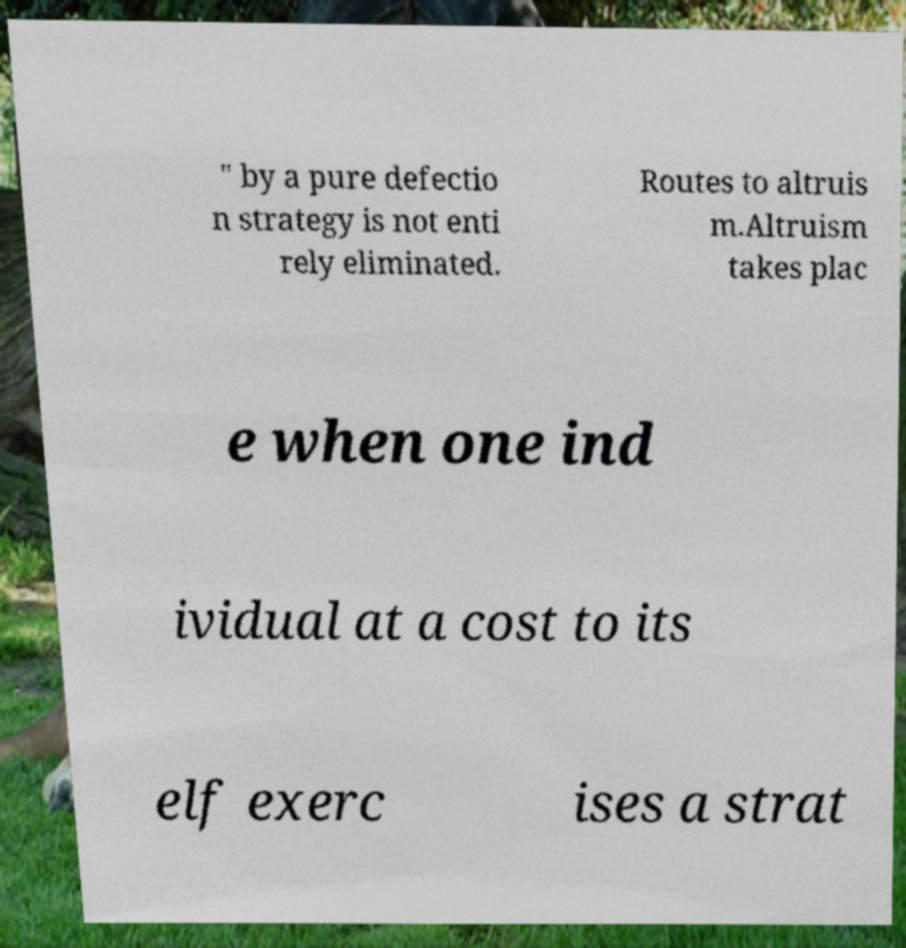What messages or text are displayed in this image? I need them in a readable, typed format. " by a pure defectio n strategy is not enti rely eliminated. Routes to altruis m.Altruism takes plac e when one ind ividual at a cost to its elf exerc ises a strat 